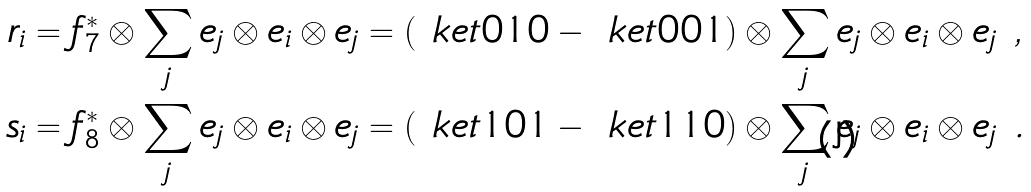Convert formula to latex. <formula><loc_0><loc_0><loc_500><loc_500>r _ { i } & = f _ { 7 } ^ { * } \otimes \sum _ { j } e _ { j } \otimes e _ { i } \otimes e _ { j } = ( \ k e t { 0 1 0 } - \ k e t { 0 0 1 } ) \otimes \sum _ { j } e _ { j } \otimes e _ { i } \otimes e _ { j } \ , \\ s _ { i } & = f _ { 8 } ^ { * } \otimes \sum _ { j } e _ { j } \otimes e _ { i } \otimes e _ { j } = ( \ k e t { 1 0 1 } - \ k e t { 1 1 0 } ) \otimes \sum _ { j } e _ { j } \otimes e _ { i } \otimes e _ { j } \ .</formula> 